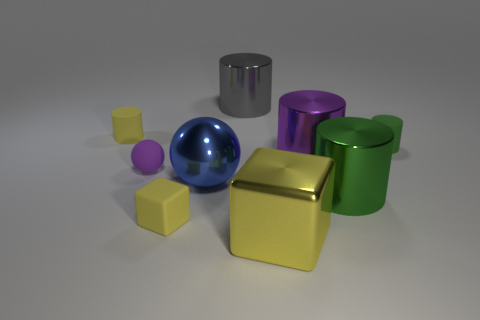What color is the tiny matte cylinder right of the big blue ball?
Keep it short and to the point. Green. What is the shape of the yellow rubber object that is behind the rubber cylinder that is to the right of the big metal block?
Your answer should be very brief. Cylinder. Is the color of the matte cube the same as the big shiny cube?
Provide a short and direct response. Yes. How many blocks are either brown metal objects or green things?
Make the answer very short. 0. What is the material of the thing that is left of the large blue thing and in front of the tiny purple matte thing?
Offer a terse response. Rubber. What number of large blue things are behind the big blue shiny thing?
Your response must be concise. 0. Do the cylinder behind the yellow matte cylinder and the tiny thing that is right of the large yellow thing have the same material?
Provide a short and direct response. No. What number of objects are green cylinders in front of the large metallic sphere or yellow things?
Keep it short and to the point. 4. Is the number of metallic objects that are behind the shiny cube less than the number of metal objects that are right of the tiny purple object?
Your response must be concise. Yes. How many other things are there of the same size as the green rubber thing?
Provide a short and direct response. 3. 